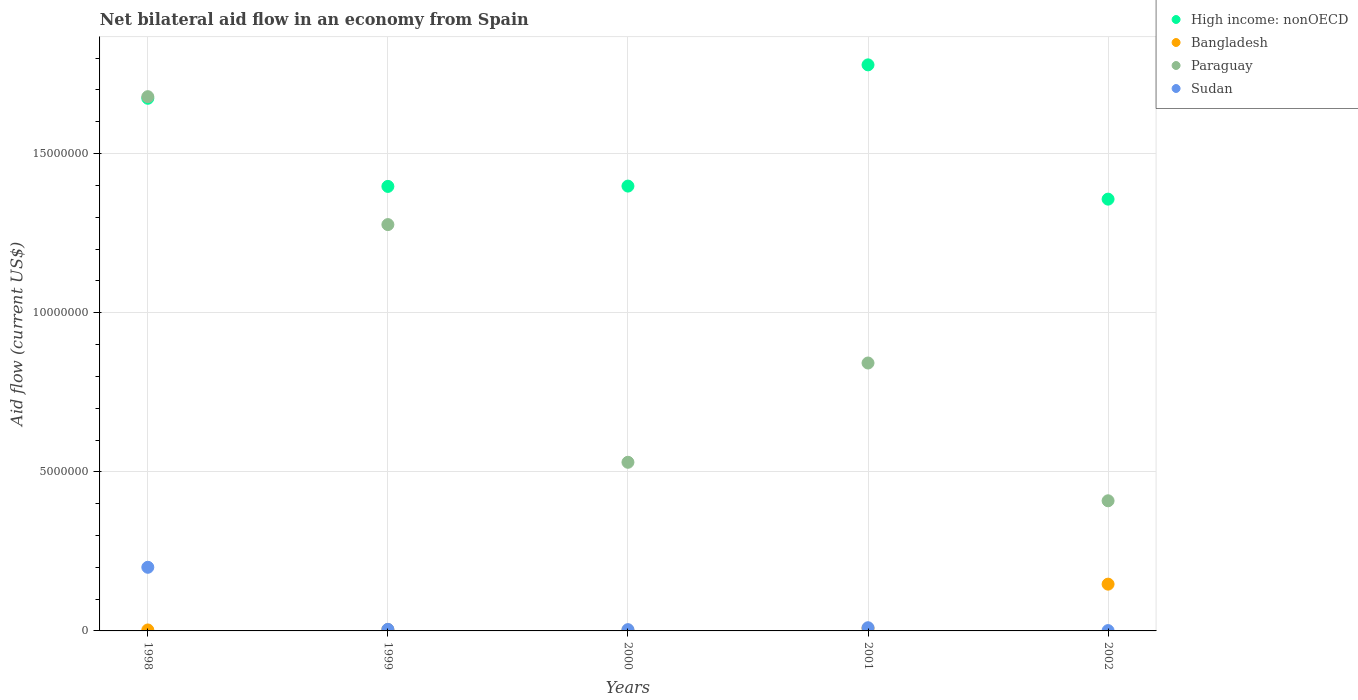How many different coloured dotlines are there?
Your response must be concise. 4. What is the net bilateral aid flow in Paraguay in 2002?
Offer a terse response. 4.09e+06. Across all years, what is the maximum net bilateral aid flow in Bangladesh?
Keep it short and to the point. 1.47e+06. Across all years, what is the minimum net bilateral aid flow in Paraguay?
Provide a short and direct response. 4.09e+06. What is the total net bilateral aid flow in Sudan in the graph?
Ensure brevity in your answer.  2.20e+06. What is the difference between the net bilateral aid flow in High income: nonOECD in 2002 and the net bilateral aid flow in Bangladesh in 1999?
Keep it short and to the point. 1.35e+07. What is the average net bilateral aid flow in Paraguay per year?
Provide a succinct answer. 9.47e+06. In the year 2000, what is the difference between the net bilateral aid flow in Paraguay and net bilateral aid flow in High income: nonOECD?
Ensure brevity in your answer.  -8.68e+06. What is the ratio of the net bilateral aid flow in Paraguay in 1999 to that in 2001?
Keep it short and to the point. 1.52. Is the net bilateral aid flow in Bangladesh in 1999 less than that in 2002?
Keep it short and to the point. Yes. What is the difference between the highest and the second highest net bilateral aid flow in Paraguay?
Offer a very short reply. 4.02e+06. What is the difference between the highest and the lowest net bilateral aid flow in Sudan?
Provide a short and direct response. 1.99e+06. Is the sum of the net bilateral aid flow in Paraguay in 2001 and 2002 greater than the maximum net bilateral aid flow in High income: nonOECD across all years?
Offer a very short reply. No. Is it the case that in every year, the sum of the net bilateral aid flow in Sudan and net bilateral aid flow in Bangladesh  is greater than the sum of net bilateral aid flow in High income: nonOECD and net bilateral aid flow in Paraguay?
Keep it short and to the point. No. Are the values on the major ticks of Y-axis written in scientific E-notation?
Provide a short and direct response. No. Does the graph contain grids?
Offer a very short reply. Yes. How many legend labels are there?
Give a very brief answer. 4. What is the title of the graph?
Offer a very short reply. Net bilateral aid flow in an economy from Spain. What is the Aid flow (current US$) in High income: nonOECD in 1998?
Offer a terse response. 1.67e+07. What is the Aid flow (current US$) in Bangladesh in 1998?
Ensure brevity in your answer.  3.00e+04. What is the Aid flow (current US$) of Paraguay in 1998?
Provide a succinct answer. 1.68e+07. What is the Aid flow (current US$) in High income: nonOECD in 1999?
Offer a very short reply. 1.40e+07. What is the Aid flow (current US$) of Paraguay in 1999?
Ensure brevity in your answer.  1.28e+07. What is the Aid flow (current US$) in Sudan in 1999?
Your response must be concise. 5.00e+04. What is the Aid flow (current US$) in High income: nonOECD in 2000?
Give a very brief answer. 1.40e+07. What is the Aid flow (current US$) in Paraguay in 2000?
Offer a terse response. 5.30e+06. What is the Aid flow (current US$) of High income: nonOECD in 2001?
Your answer should be compact. 1.78e+07. What is the Aid flow (current US$) in Bangladesh in 2001?
Your answer should be very brief. 8.00e+04. What is the Aid flow (current US$) of Paraguay in 2001?
Keep it short and to the point. 8.42e+06. What is the Aid flow (current US$) in High income: nonOECD in 2002?
Make the answer very short. 1.36e+07. What is the Aid flow (current US$) in Bangladesh in 2002?
Keep it short and to the point. 1.47e+06. What is the Aid flow (current US$) in Paraguay in 2002?
Ensure brevity in your answer.  4.09e+06. What is the Aid flow (current US$) in Sudan in 2002?
Give a very brief answer. 10000. Across all years, what is the maximum Aid flow (current US$) in High income: nonOECD?
Your response must be concise. 1.78e+07. Across all years, what is the maximum Aid flow (current US$) of Bangladesh?
Give a very brief answer. 1.47e+06. Across all years, what is the maximum Aid flow (current US$) in Paraguay?
Your answer should be very brief. 1.68e+07. Across all years, what is the maximum Aid flow (current US$) in Sudan?
Your answer should be compact. 2.00e+06. Across all years, what is the minimum Aid flow (current US$) of High income: nonOECD?
Keep it short and to the point. 1.36e+07. Across all years, what is the minimum Aid flow (current US$) in Bangladesh?
Your response must be concise. 2.00e+04. Across all years, what is the minimum Aid flow (current US$) in Paraguay?
Keep it short and to the point. 4.09e+06. What is the total Aid flow (current US$) of High income: nonOECD in the graph?
Your response must be concise. 7.60e+07. What is the total Aid flow (current US$) of Bangladesh in the graph?
Make the answer very short. 1.64e+06. What is the total Aid flow (current US$) in Paraguay in the graph?
Your answer should be very brief. 4.74e+07. What is the total Aid flow (current US$) in Sudan in the graph?
Your answer should be compact. 2.20e+06. What is the difference between the Aid flow (current US$) in High income: nonOECD in 1998 and that in 1999?
Your answer should be compact. 2.77e+06. What is the difference between the Aid flow (current US$) in Bangladesh in 1998 and that in 1999?
Give a very brief answer. -10000. What is the difference between the Aid flow (current US$) in Paraguay in 1998 and that in 1999?
Ensure brevity in your answer.  4.02e+06. What is the difference between the Aid flow (current US$) in Sudan in 1998 and that in 1999?
Provide a short and direct response. 1.95e+06. What is the difference between the Aid flow (current US$) in High income: nonOECD in 1998 and that in 2000?
Offer a very short reply. 2.76e+06. What is the difference between the Aid flow (current US$) in Paraguay in 1998 and that in 2000?
Your response must be concise. 1.15e+07. What is the difference between the Aid flow (current US$) in Sudan in 1998 and that in 2000?
Offer a very short reply. 1.96e+06. What is the difference between the Aid flow (current US$) of High income: nonOECD in 1998 and that in 2001?
Offer a very short reply. -1.05e+06. What is the difference between the Aid flow (current US$) in Paraguay in 1998 and that in 2001?
Your answer should be compact. 8.37e+06. What is the difference between the Aid flow (current US$) in Sudan in 1998 and that in 2001?
Give a very brief answer. 1.90e+06. What is the difference between the Aid flow (current US$) in High income: nonOECD in 1998 and that in 2002?
Offer a very short reply. 3.17e+06. What is the difference between the Aid flow (current US$) of Bangladesh in 1998 and that in 2002?
Give a very brief answer. -1.44e+06. What is the difference between the Aid flow (current US$) of Paraguay in 1998 and that in 2002?
Offer a very short reply. 1.27e+07. What is the difference between the Aid flow (current US$) in Sudan in 1998 and that in 2002?
Provide a short and direct response. 1.99e+06. What is the difference between the Aid flow (current US$) of High income: nonOECD in 1999 and that in 2000?
Your response must be concise. -10000. What is the difference between the Aid flow (current US$) in Bangladesh in 1999 and that in 2000?
Your answer should be compact. 2.00e+04. What is the difference between the Aid flow (current US$) in Paraguay in 1999 and that in 2000?
Keep it short and to the point. 7.47e+06. What is the difference between the Aid flow (current US$) of High income: nonOECD in 1999 and that in 2001?
Your response must be concise. -3.82e+06. What is the difference between the Aid flow (current US$) in Paraguay in 1999 and that in 2001?
Provide a succinct answer. 4.35e+06. What is the difference between the Aid flow (current US$) in Sudan in 1999 and that in 2001?
Your response must be concise. -5.00e+04. What is the difference between the Aid flow (current US$) in High income: nonOECD in 1999 and that in 2002?
Offer a very short reply. 4.00e+05. What is the difference between the Aid flow (current US$) of Bangladesh in 1999 and that in 2002?
Your response must be concise. -1.43e+06. What is the difference between the Aid flow (current US$) in Paraguay in 1999 and that in 2002?
Your answer should be compact. 8.68e+06. What is the difference between the Aid flow (current US$) in Sudan in 1999 and that in 2002?
Make the answer very short. 4.00e+04. What is the difference between the Aid flow (current US$) of High income: nonOECD in 2000 and that in 2001?
Ensure brevity in your answer.  -3.81e+06. What is the difference between the Aid flow (current US$) of Bangladesh in 2000 and that in 2001?
Ensure brevity in your answer.  -6.00e+04. What is the difference between the Aid flow (current US$) of Paraguay in 2000 and that in 2001?
Ensure brevity in your answer.  -3.12e+06. What is the difference between the Aid flow (current US$) of Sudan in 2000 and that in 2001?
Ensure brevity in your answer.  -6.00e+04. What is the difference between the Aid flow (current US$) in High income: nonOECD in 2000 and that in 2002?
Your answer should be very brief. 4.10e+05. What is the difference between the Aid flow (current US$) of Bangladesh in 2000 and that in 2002?
Make the answer very short. -1.45e+06. What is the difference between the Aid flow (current US$) in Paraguay in 2000 and that in 2002?
Your answer should be very brief. 1.21e+06. What is the difference between the Aid flow (current US$) of Sudan in 2000 and that in 2002?
Your answer should be compact. 3.00e+04. What is the difference between the Aid flow (current US$) of High income: nonOECD in 2001 and that in 2002?
Your answer should be very brief. 4.22e+06. What is the difference between the Aid flow (current US$) in Bangladesh in 2001 and that in 2002?
Keep it short and to the point. -1.39e+06. What is the difference between the Aid flow (current US$) of Paraguay in 2001 and that in 2002?
Offer a very short reply. 4.33e+06. What is the difference between the Aid flow (current US$) of Sudan in 2001 and that in 2002?
Your answer should be very brief. 9.00e+04. What is the difference between the Aid flow (current US$) in High income: nonOECD in 1998 and the Aid flow (current US$) in Bangladesh in 1999?
Make the answer very short. 1.67e+07. What is the difference between the Aid flow (current US$) in High income: nonOECD in 1998 and the Aid flow (current US$) in Paraguay in 1999?
Your answer should be very brief. 3.97e+06. What is the difference between the Aid flow (current US$) in High income: nonOECD in 1998 and the Aid flow (current US$) in Sudan in 1999?
Offer a terse response. 1.67e+07. What is the difference between the Aid flow (current US$) in Bangladesh in 1998 and the Aid flow (current US$) in Paraguay in 1999?
Your answer should be very brief. -1.27e+07. What is the difference between the Aid flow (current US$) of Paraguay in 1998 and the Aid flow (current US$) of Sudan in 1999?
Offer a terse response. 1.67e+07. What is the difference between the Aid flow (current US$) of High income: nonOECD in 1998 and the Aid flow (current US$) of Bangladesh in 2000?
Your response must be concise. 1.67e+07. What is the difference between the Aid flow (current US$) of High income: nonOECD in 1998 and the Aid flow (current US$) of Paraguay in 2000?
Offer a very short reply. 1.14e+07. What is the difference between the Aid flow (current US$) in High income: nonOECD in 1998 and the Aid flow (current US$) in Sudan in 2000?
Provide a short and direct response. 1.67e+07. What is the difference between the Aid flow (current US$) in Bangladesh in 1998 and the Aid flow (current US$) in Paraguay in 2000?
Your response must be concise. -5.27e+06. What is the difference between the Aid flow (current US$) of Bangladesh in 1998 and the Aid flow (current US$) of Sudan in 2000?
Ensure brevity in your answer.  -10000. What is the difference between the Aid flow (current US$) in Paraguay in 1998 and the Aid flow (current US$) in Sudan in 2000?
Offer a very short reply. 1.68e+07. What is the difference between the Aid flow (current US$) in High income: nonOECD in 1998 and the Aid flow (current US$) in Bangladesh in 2001?
Offer a very short reply. 1.67e+07. What is the difference between the Aid flow (current US$) in High income: nonOECD in 1998 and the Aid flow (current US$) in Paraguay in 2001?
Your answer should be very brief. 8.32e+06. What is the difference between the Aid flow (current US$) of High income: nonOECD in 1998 and the Aid flow (current US$) of Sudan in 2001?
Offer a very short reply. 1.66e+07. What is the difference between the Aid flow (current US$) in Bangladesh in 1998 and the Aid flow (current US$) in Paraguay in 2001?
Keep it short and to the point. -8.39e+06. What is the difference between the Aid flow (current US$) in Paraguay in 1998 and the Aid flow (current US$) in Sudan in 2001?
Provide a succinct answer. 1.67e+07. What is the difference between the Aid flow (current US$) in High income: nonOECD in 1998 and the Aid flow (current US$) in Bangladesh in 2002?
Give a very brief answer. 1.53e+07. What is the difference between the Aid flow (current US$) in High income: nonOECD in 1998 and the Aid flow (current US$) in Paraguay in 2002?
Offer a terse response. 1.26e+07. What is the difference between the Aid flow (current US$) of High income: nonOECD in 1998 and the Aid flow (current US$) of Sudan in 2002?
Your answer should be very brief. 1.67e+07. What is the difference between the Aid flow (current US$) in Bangladesh in 1998 and the Aid flow (current US$) in Paraguay in 2002?
Provide a short and direct response. -4.06e+06. What is the difference between the Aid flow (current US$) in Paraguay in 1998 and the Aid flow (current US$) in Sudan in 2002?
Ensure brevity in your answer.  1.68e+07. What is the difference between the Aid flow (current US$) of High income: nonOECD in 1999 and the Aid flow (current US$) of Bangladesh in 2000?
Offer a very short reply. 1.40e+07. What is the difference between the Aid flow (current US$) in High income: nonOECD in 1999 and the Aid flow (current US$) in Paraguay in 2000?
Keep it short and to the point. 8.67e+06. What is the difference between the Aid flow (current US$) of High income: nonOECD in 1999 and the Aid flow (current US$) of Sudan in 2000?
Give a very brief answer. 1.39e+07. What is the difference between the Aid flow (current US$) in Bangladesh in 1999 and the Aid flow (current US$) in Paraguay in 2000?
Ensure brevity in your answer.  -5.26e+06. What is the difference between the Aid flow (current US$) of Paraguay in 1999 and the Aid flow (current US$) of Sudan in 2000?
Offer a terse response. 1.27e+07. What is the difference between the Aid flow (current US$) in High income: nonOECD in 1999 and the Aid flow (current US$) in Bangladesh in 2001?
Your answer should be compact. 1.39e+07. What is the difference between the Aid flow (current US$) of High income: nonOECD in 1999 and the Aid flow (current US$) of Paraguay in 2001?
Your response must be concise. 5.55e+06. What is the difference between the Aid flow (current US$) in High income: nonOECD in 1999 and the Aid flow (current US$) in Sudan in 2001?
Keep it short and to the point. 1.39e+07. What is the difference between the Aid flow (current US$) of Bangladesh in 1999 and the Aid flow (current US$) of Paraguay in 2001?
Offer a very short reply. -8.38e+06. What is the difference between the Aid flow (current US$) in Bangladesh in 1999 and the Aid flow (current US$) in Sudan in 2001?
Your response must be concise. -6.00e+04. What is the difference between the Aid flow (current US$) in Paraguay in 1999 and the Aid flow (current US$) in Sudan in 2001?
Give a very brief answer. 1.27e+07. What is the difference between the Aid flow (current US$) of High income: nonOECD in 1999 and the Aid flow (current US$) of Bangladesh in 2002?
Keep it short and to the point. 1.25e+07. What is the difference between the Aid flow (current US$) of High income: nonOECD in 1999 and the Aid flow (current US$) of Paraguay in 2002?
Your response must be concise. 9.88e+06. What is the difference between the Aid flow (current US$) in High income: nonOECD in 1999 and the Aid flow (current US$) in Sudan in 2002?
Offer a terse response. 1.40e+07. What is the difference between the Aid flow (current US$) in Bangladesh in 1999 and the Aid flow (current US$) in Paraguay in 2002?
Provide a succinct answer. -4.05e+06. What is the difference between the Aid flow (current US$) of Paraguay in 1999 and the Aid flow (current US$) of Sudan in 2002?
Provide a short and direct response. 1.28e+07. What is the difference between the Aid flow (current US$) in High income: nonOECD in 2000 and the Aid flow (current US$) in Bangladesh in 2001?
Keep it short and to the point. 1.39e+07. What is the difference between the Aid flow (current US$) in High income: nonOECD in 2000 and the Aid flow (current US$) in Paraguay in 2001?
Provide a short and direct response. 5.56e+06. What is the difference between the Aid flow (current US$) in High income: nonOECD in 2000 and the Aid flow (current US$) in Sudan in 2001?
Offer a terse response. 1.39e+07. What is the difference between the Aid flow (current US$) in Bangladesh in 2000 and the Aid flow (current US$) in Paraguay in 2001?
Offer a terse response. -8.40e+06. What is the difference between the Aid flow (current US$) in Paraguay in 2000 and the Aid flow (current US$) in Sudan in 2001?
Make the answer very short. 5.20e+06. What is the difference between the Aid flow (current US$) in High income: nonOECD in 2000 and the Aid flow (current US$) in Bangladesh in 2002?
Keep it short and to the point. 1.25e+07. What is the difference between the Aid flow (current US$) of High income: nonOECD in 2000 and the Aid flow (current US$) of Paraguay in 2002?
Your answer should be very brief. 9.89e+06. What is the difference between the Aid flow (current US$) of High income: nonOECD in 2000 and the Aid flow (current US$) of Sudan in 2002?
Provide a short and direct response. 1.40e+07. What is the difference between the Aid flow (current US$) of Bangladesh in 2000 and the Aid flow (current US$) of Paraguay in 2002?
Keep it short and to the point. -4.07e+06. What is the difference between the Aid flow (current US$) of Bangladesh in 2000 and the Aid flow (current US$) of Sudan in 2002?
Give a very brief answer. 10000. What is the difference between the Aid flow (current US$) of Paraguay in 2000 and the Aid flow (current US$) of Sudan in 2002?
Your response must be concise. 5.29e+06. What is the difference between the Aid flow (current US$) of High income: nonOECD in 2001 and the Aid flow (current US$) of Bangladesh in 2002?
Provide a succinct answer. 1.63e+07. What is the difference between the Aid flow (current US$) in High income: nonOECD in 2001 and the Aid flow (current US$) in Paraguay in 2002?
Your answer should be very brief. 1.37e+07. What is the difference between the Aid flow (current US$) in High income: nonOECD in 2001 and the Aid flow (current US$) in Sudan in 2002?
Your answer should be compact. 1.78e+07. What is the difference between the Aid flow (current US$) of Bangladesh in 2001 and the Aid flow (current US$) of Paraguay in 2002?
Your response must be concise. -4.01e+06. What is the difference between the Aid flow (current US$) in Bangladesh in 2001 and the Aid flow (current US$) in Sudan in 2002?
Keep it short and to the point. 7.00e+04. What is the difference between the Aid flow (current US$) of Paraguay in 2001 and the Aid flow (current US$) of Sudan in 2002?
Offer a very short reply. 8.41e+06. What is the average Aid flow (current US$) of High income: nonOECD per year?
Keep it short and to the point. 1.52e+07. What is the average Aid flow (current US$) in Bangladesh per year?
Provide a short and direct response. 3.28e+05. What is the average Aid flow (current US$) in Paraguay per year?
Ensure brevity in your answer.  9.47e+06. In the year 1998, what is the difference between the Aid flow (current US$) of High income: nonOECD and Aid flow (current US$) of Bangladesh?
Ensure brevity in your answer.  1.67e+07. In the year 1998, what is the difference between the Aid flow (current US$) in High income: nonOECD and Aid flow (current US$) in Paraguay?
Offer a very short reply. -5.00e+04. In the year 1998, what is the difference between the Aid flow (current US$) of High income: nonOECD and Aid flow (current US$) of Sudan?
Provide a succinct answer. 1.47e+07. In the year 1998, what is the difference between the Aid flow (current US$) of Bangladesh and Aid flow (current US$) of Paraguay?
Your answer should be very brief. -1.68e+07. In the year 1998, what is the difference between the Aid flow (current US$) in Bangladesh and Aid flow (current US$) in Sudan?
Your answer should be very brief. -1.97e+06. In the year 1998, what is the difference between the Aid flow (current US$) of Paraguay and Aid flow (current US$) of Sudan?
Give a very brief answer. 1.48e+07. In the year 1999, what is the difference between the Aid flow (current US$) in High income: nonOECD and Aid flow (current US$) in Bangladesh?
Your response must be concise. 1.39e+07. In the year 1999, what is the difference between the Aid flow (current US$) of High income: nonOECD and Aid flow (current US$) of Paraguay?
Make the answer very short. 1.20e+06. In the year 1999, what is the difference between the Aid flow (current US$) of High income: nonOECD and Aid flow (current US$) of Sudan?
Your answer should be very brief. 1.39e+07. In the year 1999, what is the difference between the Aid flow (current US$) of Bangladesh and Aid flow (current US$) of Paraguay?
Your response must be concise. -1.27e+07. In the year 1999, what is the difference between the Aid flow (current US$) in Paraguay and Aid flow (current US$) in Sudan?
Your response must be concise. 1.27e+07. In the year 2000, what is the difference between the Aid flow (current US$) in High income: nonOECD and Aid flow (current US$) in Bangladesh?
Provide a succinct answer. 1.40e+07. In the year 2000, what is the difference between the Aid flow (current US$) in High income: nonOECD and Aid flow (current US$) in Paraguay?
Ensure brevity in your answer.  8.68e+06. In the year 2000, what is the difference between the Aid flow (current US$) of High income: nonOECD and Aid flow (current US$) of Sudan?
Offer a terse response. 1.39e+07. In the year 2000, what is the difference between the Aid flow (current US$) of Bangladesh and Aid flow (current US$) of Paraguay?
Offer a terse response. -5.28e+06. In the year 2000, what is the difference between the Aid flow (current US$) in Bangladesh and Aid flow (current US$) in Sudan?
Provide a succinct answer. -2.00e+04. In the year 2000, what is the difference between the Aid flow (current US$) in Paraguay and Aid flow (current US$) in Sudan?
Ensure brevity in your answer.  5.26e+06. In the year 2001, what is the difference between the Aid flow (current US$) in High income: nonOECD and Aid flow (current US$) in Bangladesh?
Give a very brief answer. 1.77e+07. In the year 2001, what is the difference between the Aid flow (current US$) in High income: nonOECD and Aid flow (current US$) in Paraguay?
Your response must be concise. 9.37e+06. In the year 2001, what is the difference between the Aid flow (current US$) of High income: nonOECD and Aid flow (current US$) of Sudan?
Offer a terse response. 1.77e+07. In the year 2001, what is the difference between the Aid flow (current US$) in Bangladesh and Aid flow (current US$) in Paraguay?
Your answer should be compact. -8.34e+06. In the year 2001, what is the difference between the Aid flow (current US$) of Bangladesh and Aid flow (current US$) of Sudan?
Keep it short and to the point. -2.00e+04. In the year 2001, what is the difference between the Aid flow (current US$) in Paraguay and Aid flow (current US$) in Sudan?
Your answer should be very brief. 8.32e+06. In the year 2002, what is the difference between the Aid flow (current US$) of High income: nonOECD and Aid flow (current US$) of Bangladesh?
Provide a succinct answer. 1.21e+07. In the year 2002, what is the difference between the Aid flow (current US$) of High income: nonOECD and Aid flow (current US$) of Paraguay?
Offer a terse response. 9.48e+06. In the year 2002, what is the difference between the Aid flow (current US$) in High income: nonOECD and Aid flow (current US$) in Sudan?
Make the answer very short. 1.36e+07. In the year 2002, what is the difference between the Aid flow (current US$) of Bangladesh and Aid flow (current US$) of Paraguay?
Ensure brevity in your answer.  -2.62e+06. In the year 2002, what is the difference between the Aid flow (current US$) of Bangladesh and Aid flow (current US$) of Sudan?
Your answer should be very brief. 1.46e+06. In the year 2002, what is the difference between the Aid flow (current US$) of Paraguay and Aid flow (current US$) of Sudan?
Provide a short and direct response. 4.08e+06. What is the ratio of the Aid flow (current US$) of High income: nonOECD in 1998 to that in 1999?
Your answer should be very brief. 1.2. What is the ratio of the Aid flow (current US$) in Bangladesh in 1998 to that in 1999?
Provide a succinct answer. 0.75. What is the ratio of the Aid flow (current US$) of Paraguay in 1998 to that in 1999?
Offer a very short reply. 1.31. What is the ratio of the Aid flow (current US$) in High income: nonOECD in 1998 to that in 2000?
Keep it short and to the point. 1.2. What is the ratio of the Aid flow (current US$) in Paraguay in 1998 to that in 2000?
Make the answer very short. 3.17. What is the ratio of the Aid flow (current US$) of Sudan in 1998 to that in 2000?
Offer a terse response. 50. What is the ratio of the Aid flow (current US$) in High income: nonOECD in 1998 to that in 2001?
Your response must be concise. 0.94. What is the ratio of the Aid flow (current US$) of Bangladesh in 1998 to that in 2001?
Ensure brevity in your answer.  0.38. What is the ratio of the Aid flow (current US$) in Paraguay in 1998 to that in 2001?
Ensure brevity in your answer.  1.99. What is the ratio of the Aid flow (current US$) in Sudan in 1998 to that in 2001?
Keep it short and to the point. 20. What is the ratio of the Aid flow (current US$) in High income: nonOECD in 1998 to that in 2002?
Give a very brief answer. 1.23. What is the ratio of the Aid flow (current US$) of Bangladesh in 1998 to that in 2002?
Your response must be concise. 0.02. What is the ratio of the Aid flow (current US$) in Paraguay in 1998 to that in 2002?
Keep it short and to the point. 4.11. What is the ratio of the Aid flow (current US$) in High income: nonOECD in 1999 to that in 2000?
Offer a terse response. 1. What is the ratio of the Aid flow (current US$) of Paraguay in 1999 to that in 2000?
Keep it short and to the point. 2.41. What is the ratio of the Aid flow (current US$) in High income: nonOECD in 1999 to that in 2001?
Keep it short and to the point. 0.79. What is the ratio of the Aid flow (current US$) of Bangladesh in 1999 to that in 2001?
Offer a very short reply. 0.5. What is the ratio of the Aid flow (current US$) in Paraguay in 1999 to that in 2001?
Provide a succinct answer. 1.52. What is the ratio of the Aid flow (current US$) in Sudan in 1999 to that in 2001?
Keep it short and to the point. 0.5. What is the ratio of the Aid flow (current US$) of High income: nonOECD in 1999 to that in 2002?
Your answer should be compact. 1.03. What is the ratio of the Aid flow (current US$) of Bangladesh in 1999 to that in 2002?
Make the answer very short. 0.03. What is the ratio of the Aid flow (current US$) of Paraguay in 1999 to that in 2002?
Keep it short and to the point. 3.12. What is the ratio of the Aid flow (current US$) in Sudan in 1999 to that in 2002?
Ensure brevity in your answer.  5. What is the ratio of the Aid flow (current US$) of High income: nonOECD in 2000 to that in 2001?
Your response must be concise. 0.79. What is the ratio of the Aid flow (current US$) in Bangladesh in 2000 to that in 2001?
Make the answer very short. 0.25. What is the ratio of the Aid flow (current US$) of Paraguay in 2000 to that in 2001?
Your answer should be very brief. 0.63. What is the ratio of the Aid flow (current US$) of High income: nonOECD in 2000 to that in 2002?
Ensure brevity in your answer.  1.03. What is the ratio of the Aid flow (current US$) in Bangladesh in 2000 to that in 2002?
Ensure brevity in your answer.  0.01. What is the ratio of the Aid flow (current US$) of Paraguay in 2000 to that in 2002?
Provide a short and direct response. 1.3. What is the ratio of the Aid flow (current US$) in High income: nonOECD in 2001 to that in 2002?
Your response must be concise. 1.31. What is the ratio of the Aid flow (current US$) in Bangladesh in 2001 to that in 2002?
Offer a very short reply. 0.05. What is the ratio of the Aid flow (current US$) in Paraguay in 2001 to that in 2002?
Keep it short and to the point. 2.06. What is the difference between the highest and the second highest Aid flow (current US$) of High income: nonOECD?
Provide a short and direct response. 1.05e+06. What is the difference between the highest and the second highest Aid flow (current US$) in Bangladesh?
Make the answer very short. 1.39e+06. What is the difference between the highest and the second highest Aid flow (current US$) in Paraguay?
Offer a terse response. 4.02e+06. What is the difference between the highest and the second highest Aid flow (current US$) in Sudan?
Your answer should be compact. 1.90e+06. What is the difference between the highest and the lowest Aid flow (current US$) of High income: nonOECD?
Your response must be concise. 4.22e+06. What is the difference between the highest and the lowest Aid flow (current US$) in Bangladesh?
Your answer should be very brief. 1.45e+06. What is the difference between the highest and the lowest Aid flow (current US$) in Paraguay?
Your answer should be very brief. 1.27e+07. What is the difference between the highest and the lowest Aid flow (current US$) in Sudan?
Your answer should be compact. 1.99e+06. 